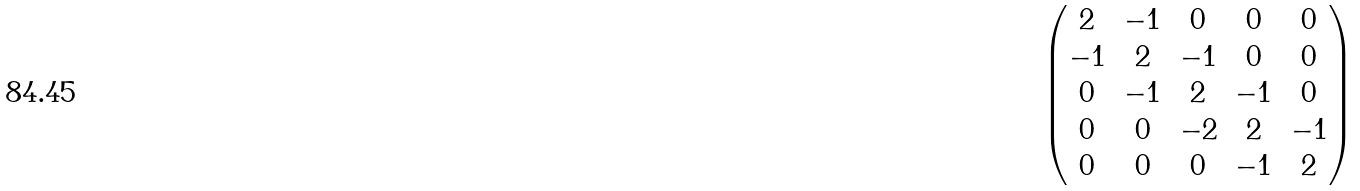Convert formula to latex. <formula><loc_0><loc_0><loc_500><loc_500>\begin{pmatrix} 2 & - 1 & 0 & 0 & 0 \\ - 1 & 2 & - 1 & 0 & 0 \\ 0 & - 1 & 2 & - 1 & 0 \\ 0 & 0 & - 2 & 2 & - 1 \\ 0 & 0 & 0 & - 1 & 2 \end{pmatrix}</formula> 